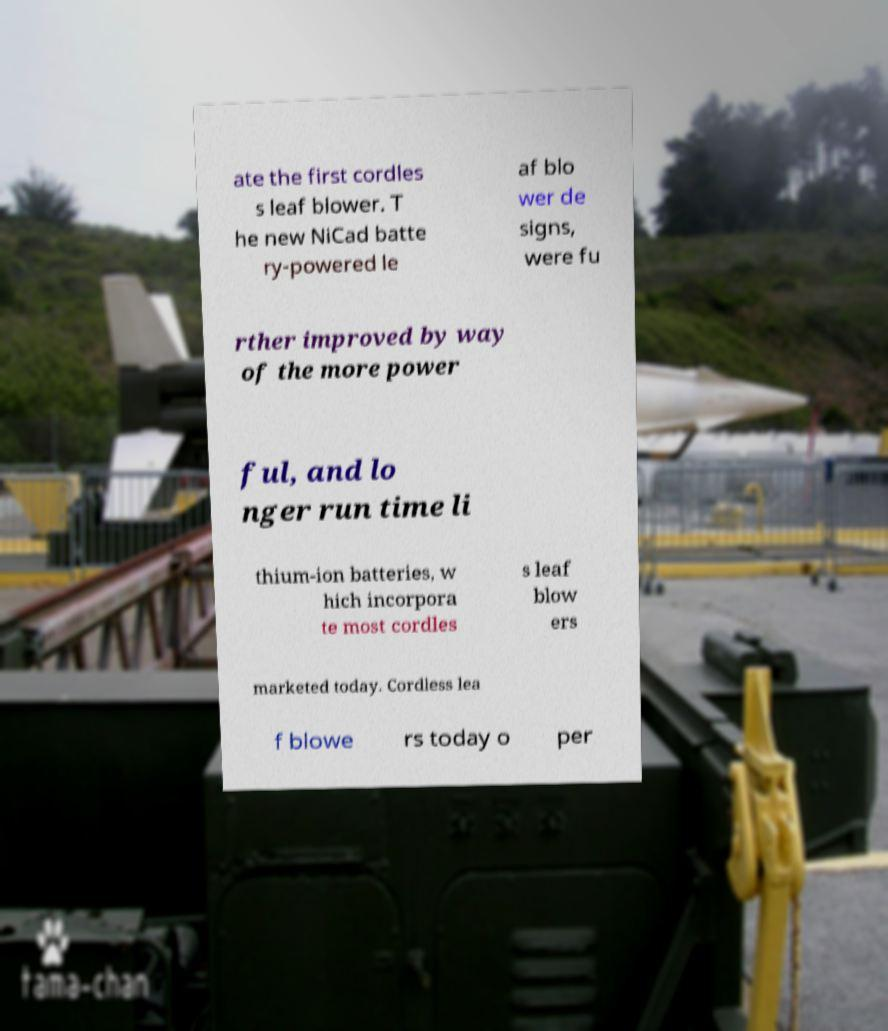Can you read and provide the text displayed in the image?This photo seems to have some interesting text. Can you extract and type it out for me? ate the first cordles s leaf blower. T he new NiCad batte ry-powered le af blo wer de signs, were fu rther improved by way of the more power ful, and lo nger run time li thium-ion batteries, w hich incorpora te most cordles s leaf blow ers marketed today. Cordless lea f blowe rs today o per 